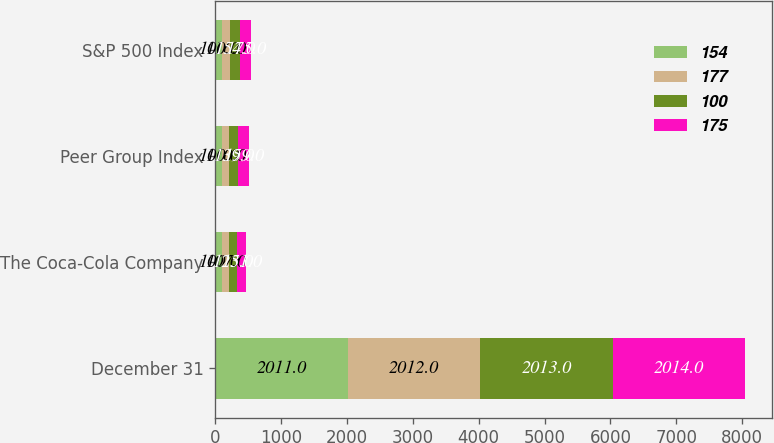Convert chart. <chart><loc_0><loc_0><loc_500><loc_500><stacked_bar_chart><ecel><fcel>December 31<fcel>The Coca-Cola Company<fcel>Peer Group Index<fcel>S&P 500 Index<nl><fcel>154<fcel>2011<fcel>100<fcel>100<fcel>100<nl><fcel>177<fcel>2012<fcel>107<fcel>110<fcel>116<nl><fcel>100<fcel>2013<fcel>125<fcel>139<fcel>154<nl><fcel>175<fcel>2014<fcel>131<fcel>159<fcel>175<nl></chart> 